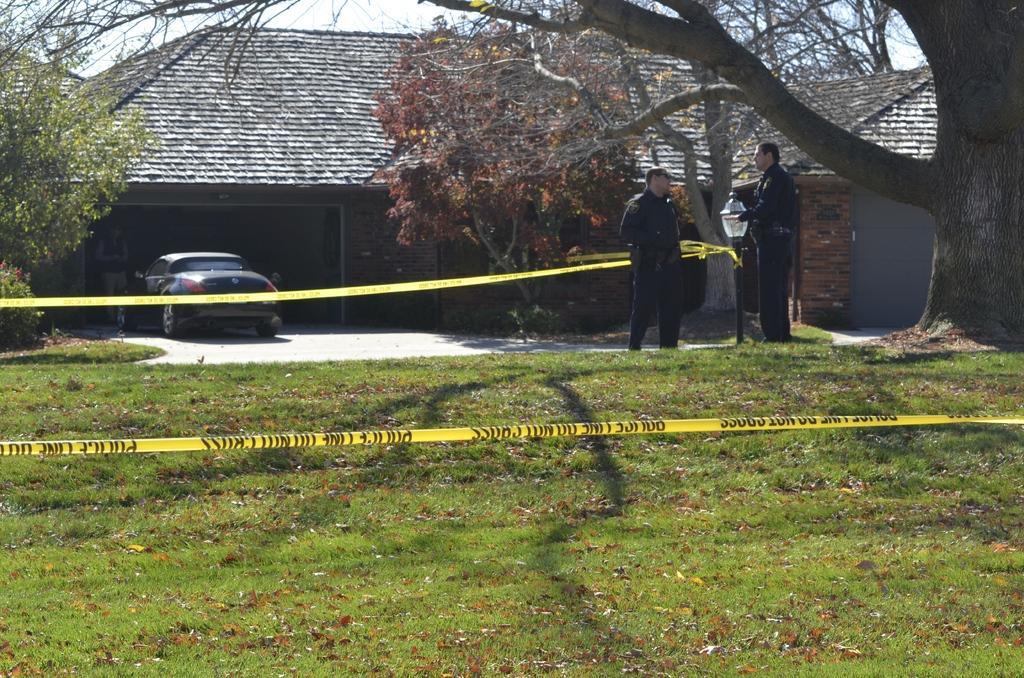Please provide a concise description of this image. There are men those who are standing on the right side of the image, in front of a lamp pole and there are barrier tapes and grassland in the foreground area, there is a car and a house in the background area, there is a tree on the right side and there is sky in the background area. 